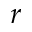<formula> <loc_0><loc_0><loc_500><loc_500>r</formula> 